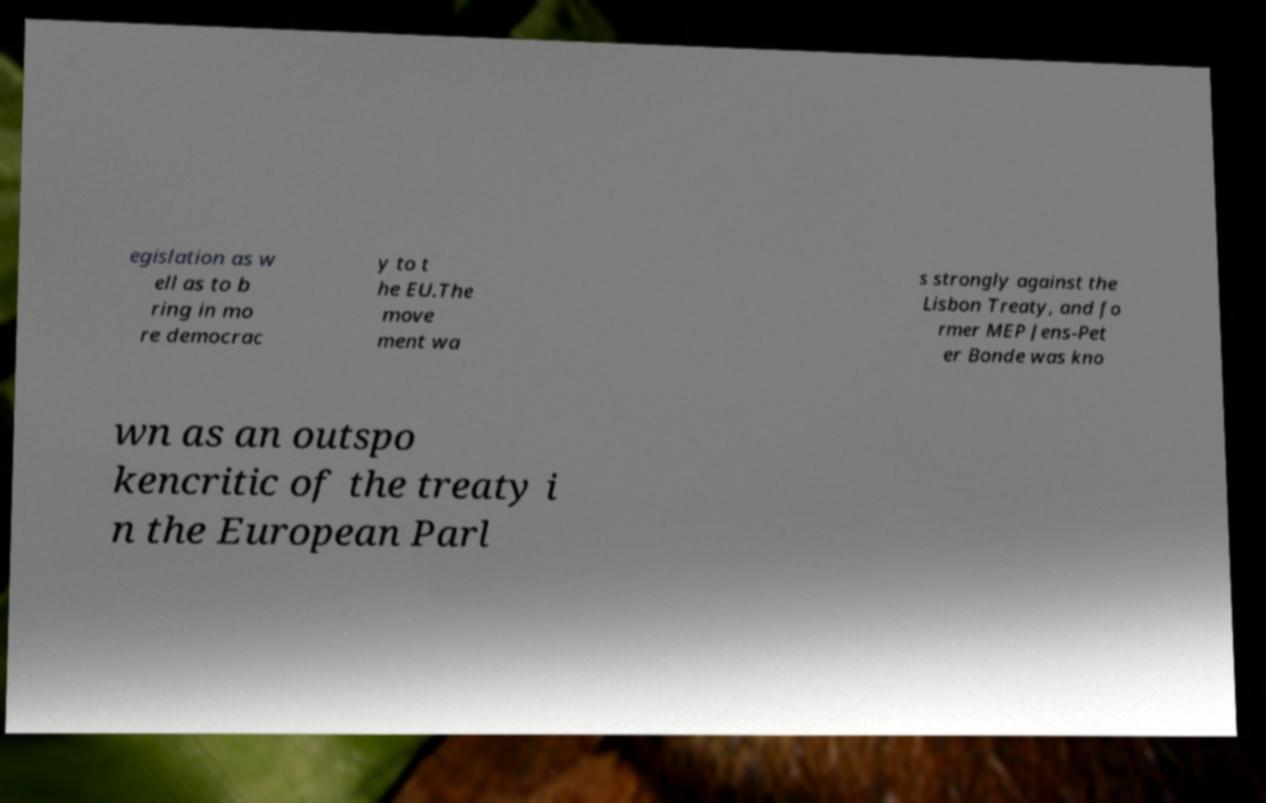Could you extract and type out the text from this image? egislation as w ell as to b ring in mo re democrac y to t he EU.The move ment wa s strongly against the Lisbon Treaty, and fo rmer MEP Jens-Pet er Bonde was kno wn as an outspo kencritic of the treaty i n the European Parl 